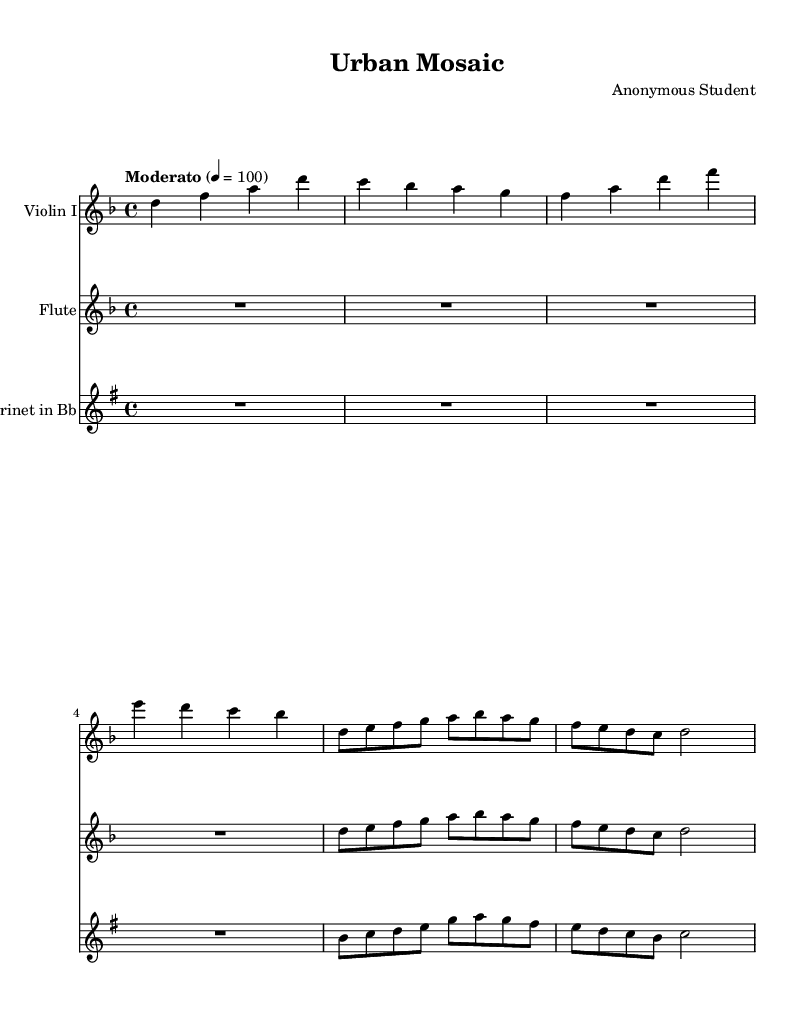What is the key signature of this music? The key signature is D minor, which is represented by one flat (B flat) on the staff.
Answer: D minor What is the time signature of this piece? The time signature is 4/4, which indicates that there are four beats in each measure and the quarter note gets one beat.
Answer: 4/4 What is the tempo indication given for this piece? The tempo is marked as "Moderato," which suggests a moderate speed, generally around 100 beats per minute as indicated by the metronome marking.
Answer: Moderato How many measures are present in the violin part? By counting the measures in the violin part, we see there are six measures. Each grouping of notes between the bar lines represents one measure.
Answer: Six What is the range of instruments used in this composition? The score features three instruments: Violin I, Flute, and Clarinet in B flat, indicating a blend of string and woodwind timbres.
Answer: Violin I, Flute, Clarinet in B flat What is the rhythm pattern of the first measure in the flute part? The first measure in the flute part is marked by a rest (indicated as "R1*4"), which means no notes are played during this measure, followed by a series of eighth notes in the next measure.
Answer: Rest Which instrument plays the highest pitch in this composition? The Violin I part plays the highest pitches, starting at D in the second octave and reaching up to D one octave higher in the series of notes in its part.
Answer: Violin I 